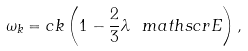Convert formula to latex. <formula><loc_0><loc_0><loc_500><loc_500>\omega _ { k } = c k \left ( 1 - \frac { 2 } { 3 } \lambda \ m a t h s c r { E } \right ) ,</formula> 